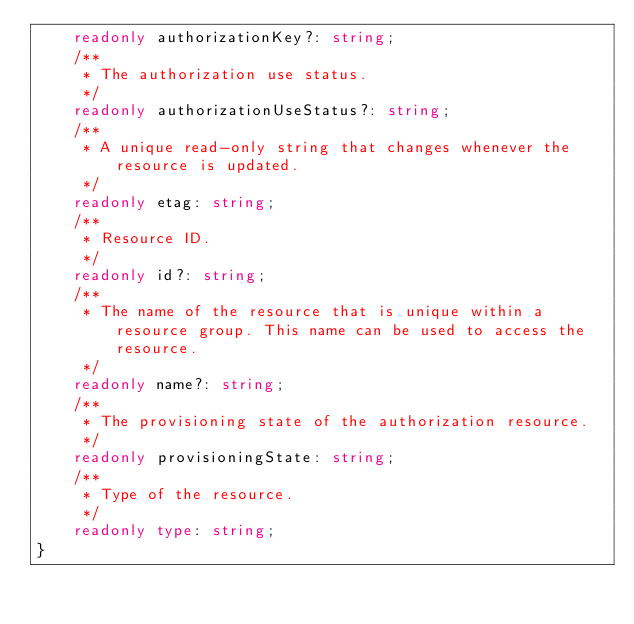<code> <loc_0><loc_0><loc_500><loc_500><_TypeScript_>    readonly authorizationKey?: string;
    /**
     * The authorization use status.
     */
    readonly authorizationUseStatus?: string;
    /**
     * A unique read-only string that changes whenever the resource is updated.
     */
    readonly etag: string;
    /**
     * Resource ID.
     */
    readonly id?: string;
    /**
     * The name of the resource that is unique within a resource group. This name can be used to access the resource.
     */
    readonly name?: string;
    /**
     * The provisioning state of the authorization resource.
     */
    readonly provisioningState: string;
    /**
     * Type of the resource.
     */
    readonly type: string;
}
</code> 